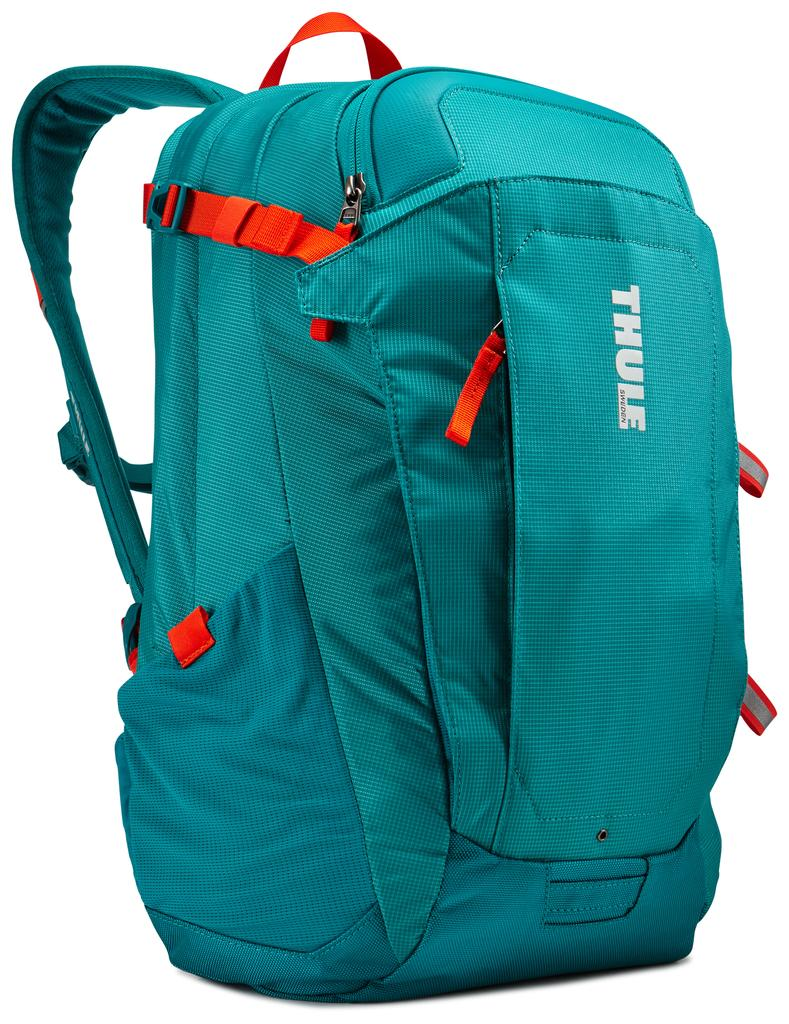<image>
Offer a succinct explanation of the picture presented. a blue and orange Thule back pack is on display 